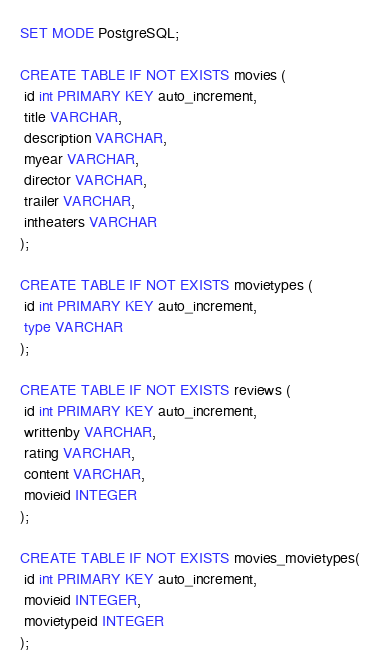Convert code to text. <code><loc_0><loc_0><loc_500><loc_500><_SQL_>SET MODE PostgreSQL;

CREATE TABLE IF NOT EXISTS movies (
 id int PRIMARY KEY auto_increment,
 title VARCHAR,
 description VARCHAR,
 myear VARCHAR,
 director VARCHAR,
 trailer VARCHAR,
 intheaters VARCHAR
);

CREATE TABLE IF NOT EXISTS movietypes (
 id int PRIMARY KEY auto_increment,
 type VARCHAR
);

CREATE TABLE IF NOT EXISTS reviews (
 id int PRIMARY KEY auto_increment,
 writtenby VARCHAR,
 rating VARCHAR,
 content VARCHAR,
 movieid INTEGER
);

CREATE TABLE IF NOT EXISTS movies_movietypes(
 id int PRIMARY KEY auto_increment,
 movieid INTEGER,
 movietypeid INTEGER
);</code> 